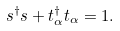<formula> <loc_0><loc_0><loc_500><loc_500>s ^ { \dagger } s + t ^ { \dagger } _ { \alpha } t _ { \alpha } = 1 .</formula> 